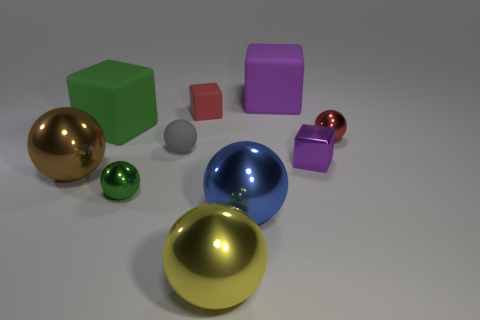Subtract all yellow metal balls. How many balls are left? 5 Subtract 1 spheres. How many spheres are left? 5 Subtract all green balls. How many balls are left? 5 Subtract all cyan cubes. Subtract all cyan spheres. How many cubes are left? 4 Subtract all blocks. How many objects are left? 6 Subtract all small blue cubes. Subtract all gray spheres. How many objects are left? 9 Add 4 red metal things. How many red metal things are left? 5 Add 5 tiny blue rubber objects. How many tiny blue rubber objects exist? 5 Subtract 0 cyan cylinders. How many objects are left? 10 